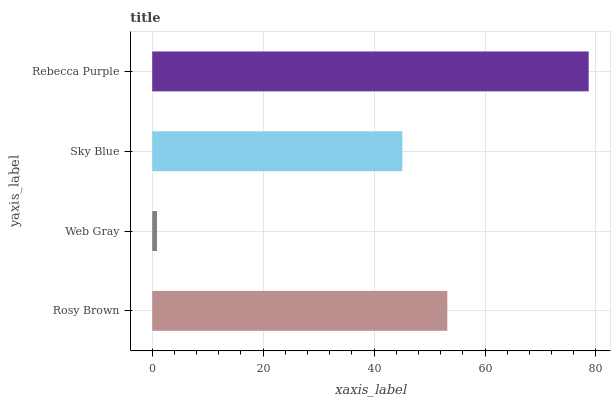Is Web Gray the minimum?
Answer yes or no. Yes. Is Rebecca Purple the maximum?
Answer yes or no. Yes. Is Sky Blue the minimum?
Answer yes or no. No. Is Sky Blue the maximum?
Answer yes or no. No. Is Sky Blue greater than Web Gray?
Answer yes or no. Yes. Is Web Gray less than Sky Blue?
Answer yes or no. Yes. Is Web Gray greater than Sky Blue?
Answer yes or no. No. Is Sky Blue less than Web Gray?
Answer yes or no. No. Is Rosy Brown the high median?
Answer yes or no. Yes. Is Sky Blue the low median?
Answer yes or no. Yes. Is Rebecca Purple the high median?
Answer yes or no. No. Is Rosy Brown the low median?
Answer yes or no. No. 